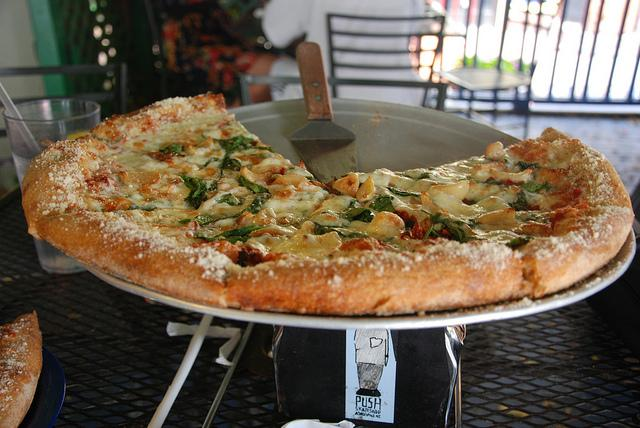What ingredients are on the pizza? Please explain your reasoning. spinach. There green veggie on the pizza is spinach because it withered away after cooking. 